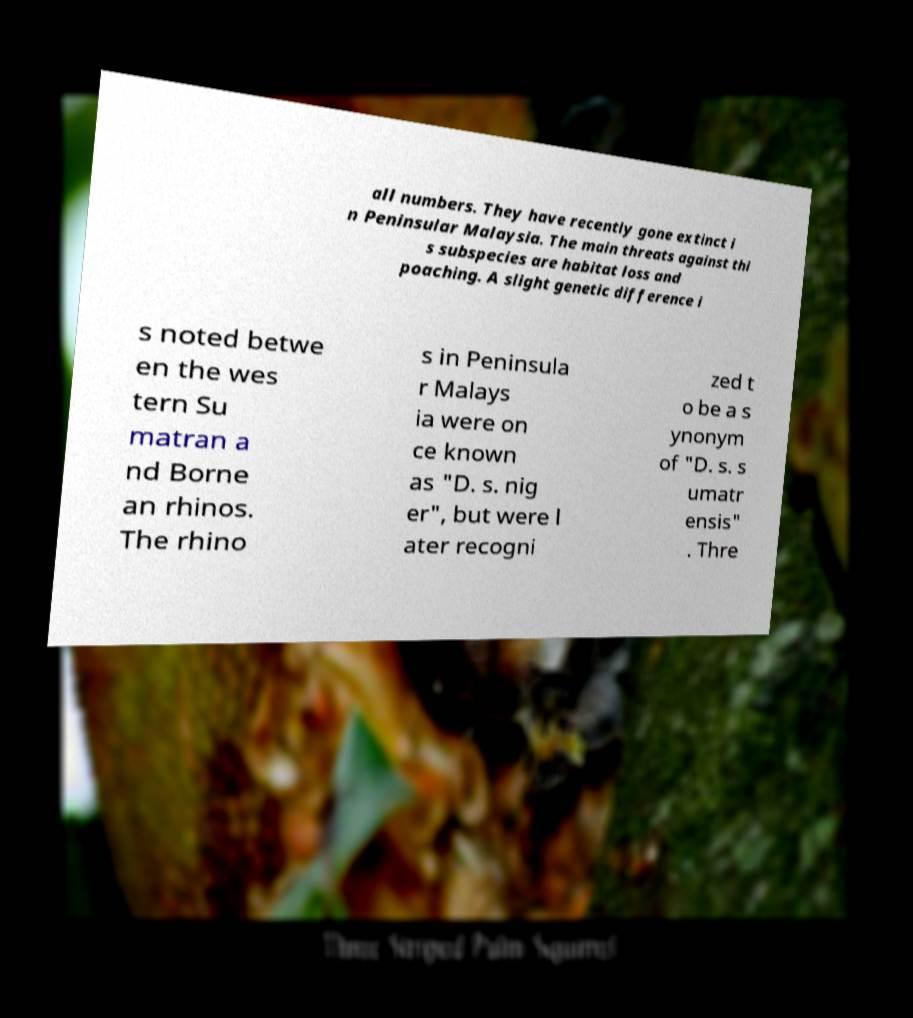Could you extract and type out the text from this image? all numbers. They have recently gone extinct i n Peninsular Malaysia. The main threats against thi s subspecies are habitat loss and poaching. A slight genetic difference i s noted betwe en the wes tern Su matran a nd Borne an rhinos. The rhino s in Peninsula r Malays ia were on ce known as "D. s. nig er", but were l ater recogni zed t o be a s ynonym of "D. s. s umatr ensis" . Thre 